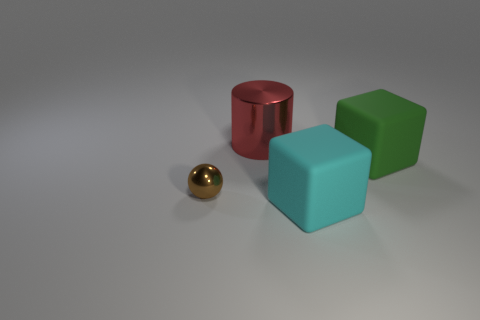Add 4 blue cylinders. How many objects exist? 8 Subtract all cylinders. How many objects are left? 3 Subtract all tiny gray cubes. Subtract all tiny balls. How many objects are left? 3 Add 3 tiny metallic objects. How many tiny metallic objects are left? 4 Add 2 small cyan matte objects. How many small cyan matte objects exist? 2 Subtract 1 cyan blocks. How many objects are left? 3 